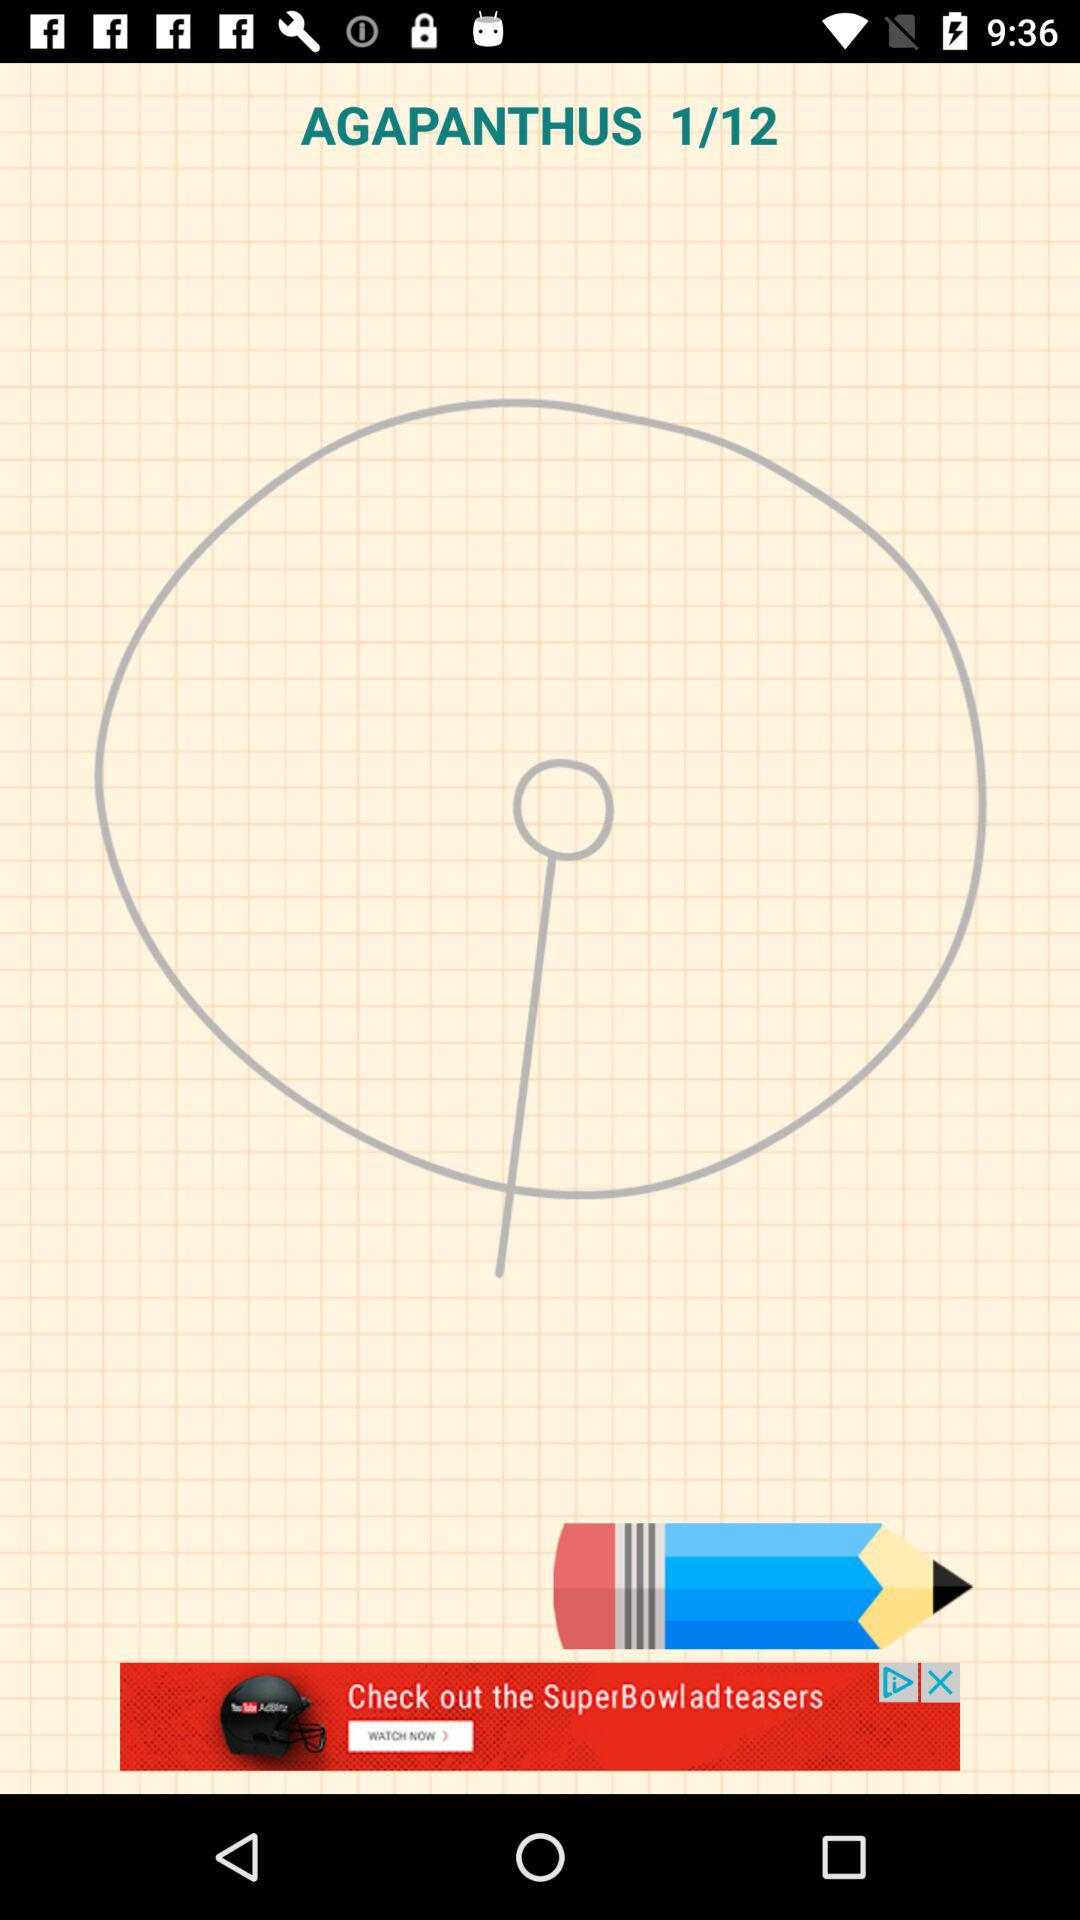What is the currently open page number? The currently open page number is 1. 